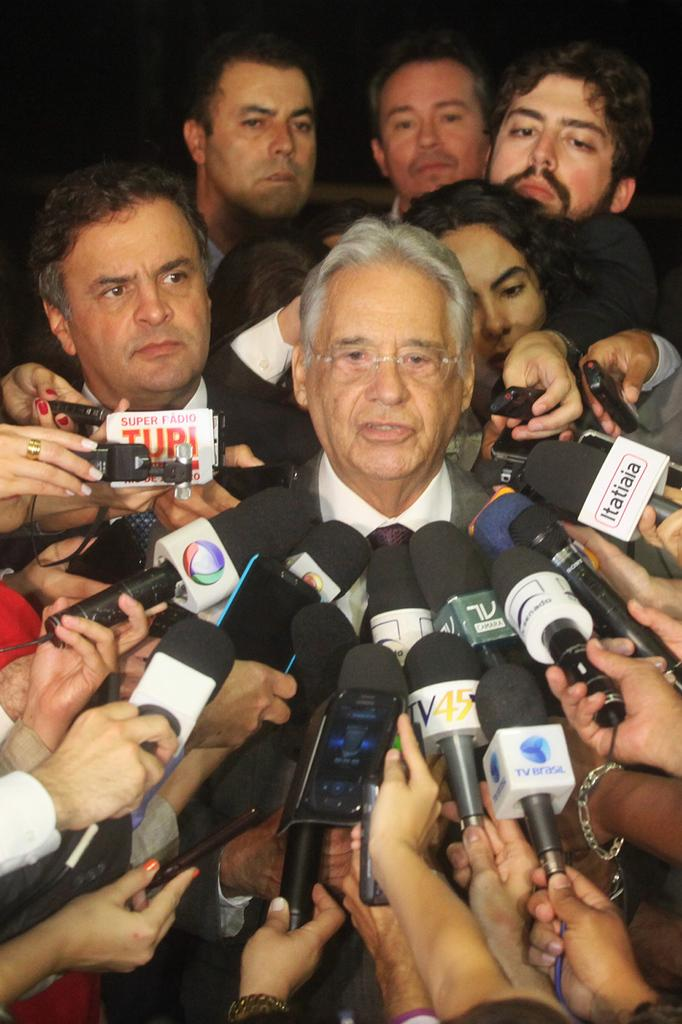What is happening in the image? There are people standing in the image, and some of them are holding microphones in their hands. Who is speaking in the image? A man is speaking in the image. What type of poison is the man using in the image? There is no poison present in the image; the man is simply speaking. How does the brother contribute to the scene in the image? There is no mention of a brother in the image, so it is not possible to answer that question. 